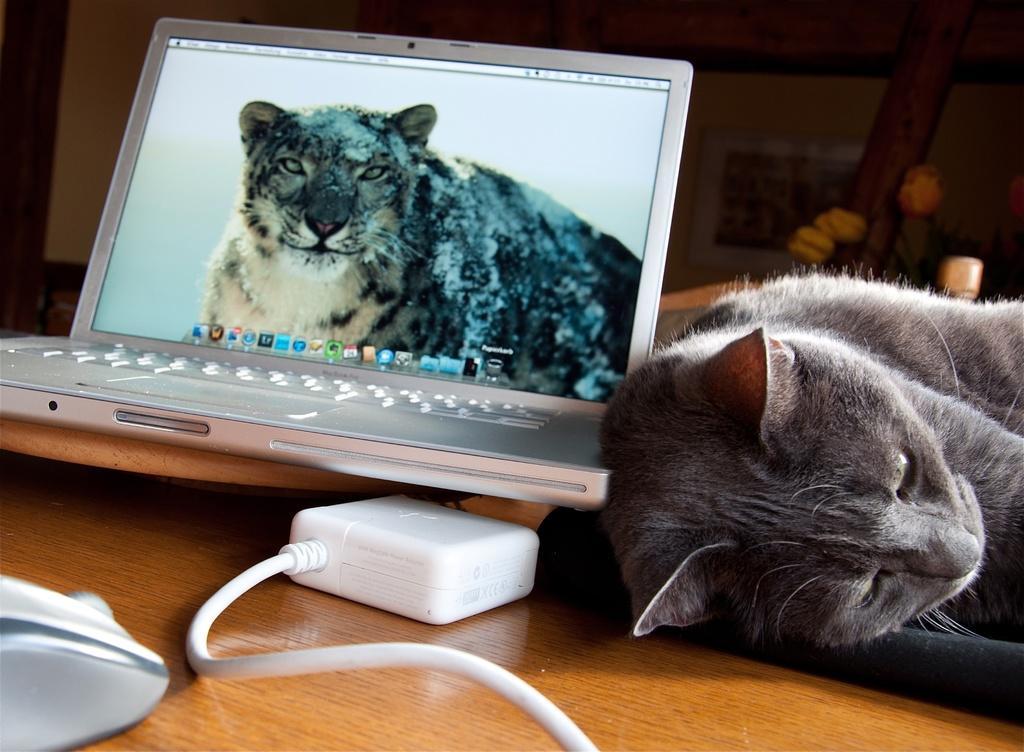Please provide a concise description of this image. In this image there is a table and we can see a cat lying on the table and we can see a laptop and a wire placed on the table. In the background there is a wall. 